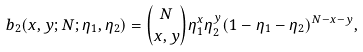Convert formula to latex. <formula><loc_0><loc_0><loc_500><loc_500>b _ { 2 } ( x , y ; N ; \eta _ { 1 } , \eta _ { 2 } ) = { N \choose x , y } \eta ^ { x } _ { 1 } \eta ^ { y } _ { 2 } ( 1 - \eta _ { 1 } - \eta _ { 2 } ) ^ { N - x - y } ,</formula> 